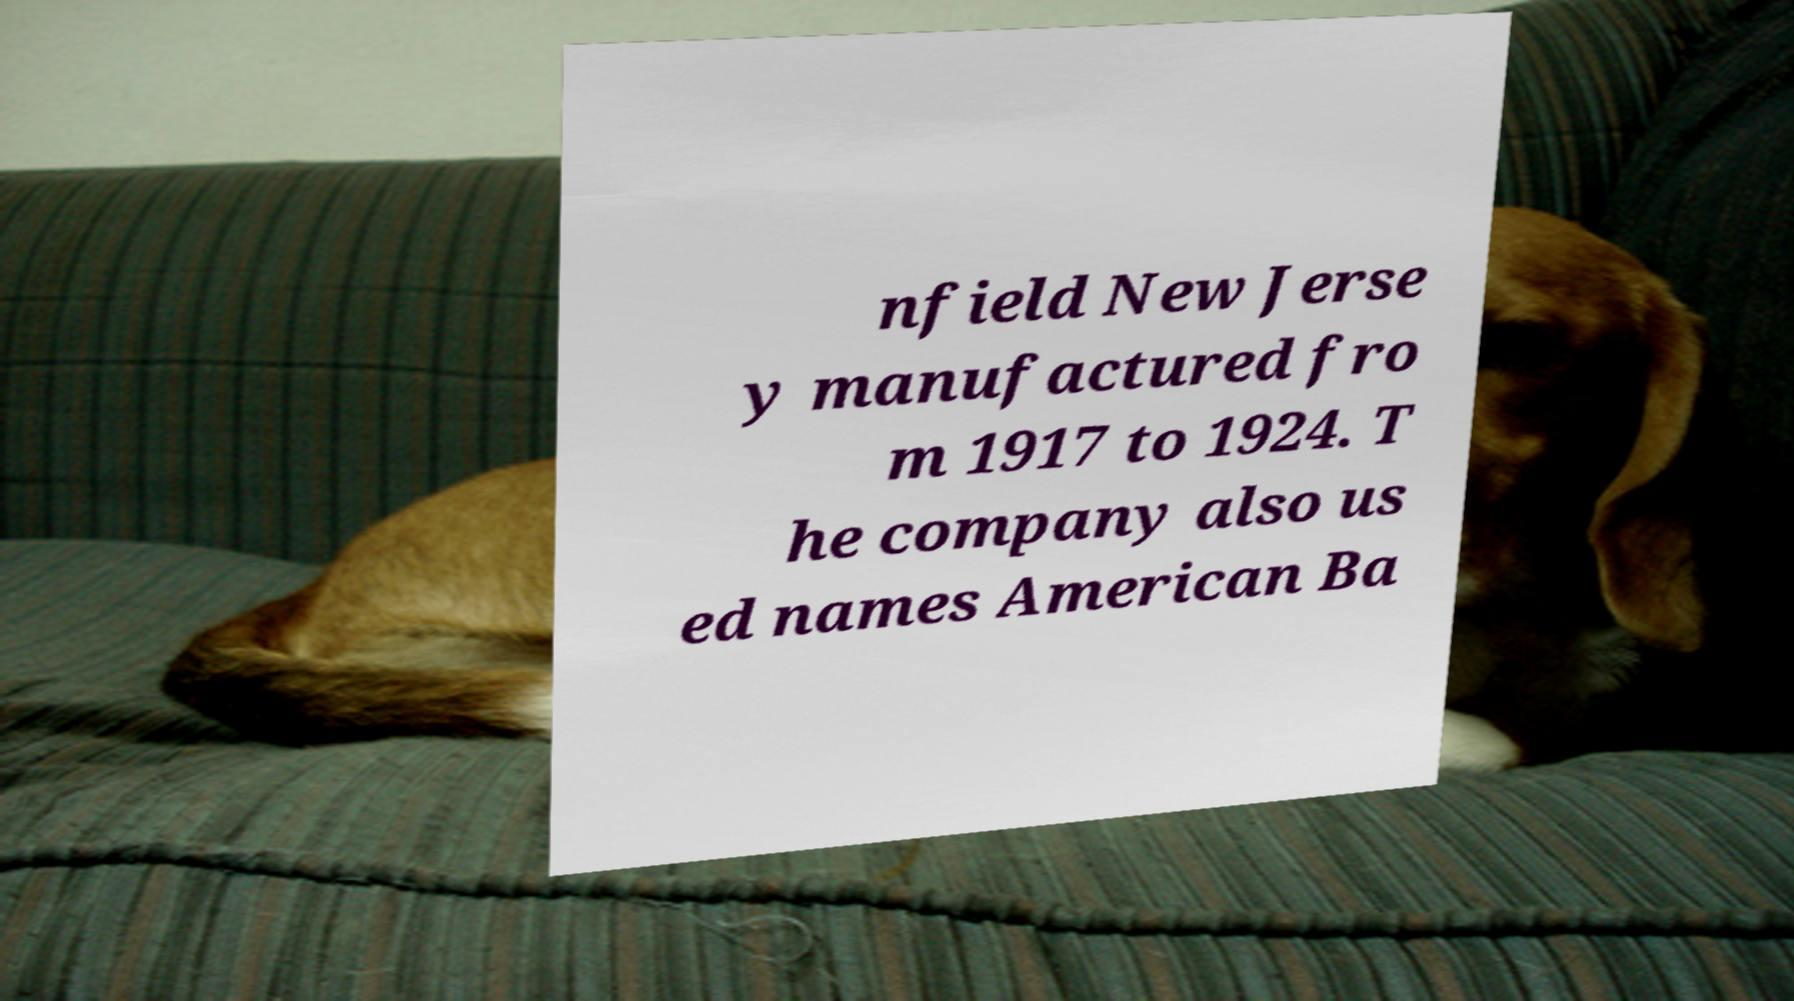What messages or text are displayed in this image? I need them in a readable, typed format. nfield New Jerse y manufactured fro m 1917 to 1924. T he company also us ed names American Ba 